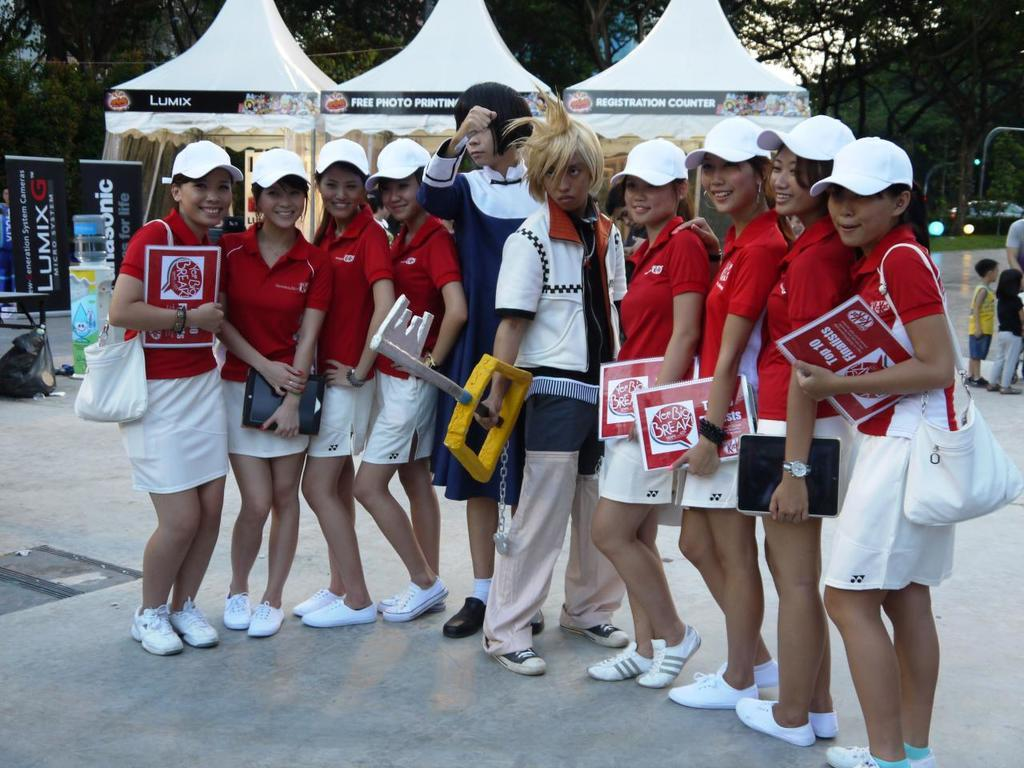<image>
Create a compact narrative representing the image presented. Women in white hats are holding papers that have the word break on them. 